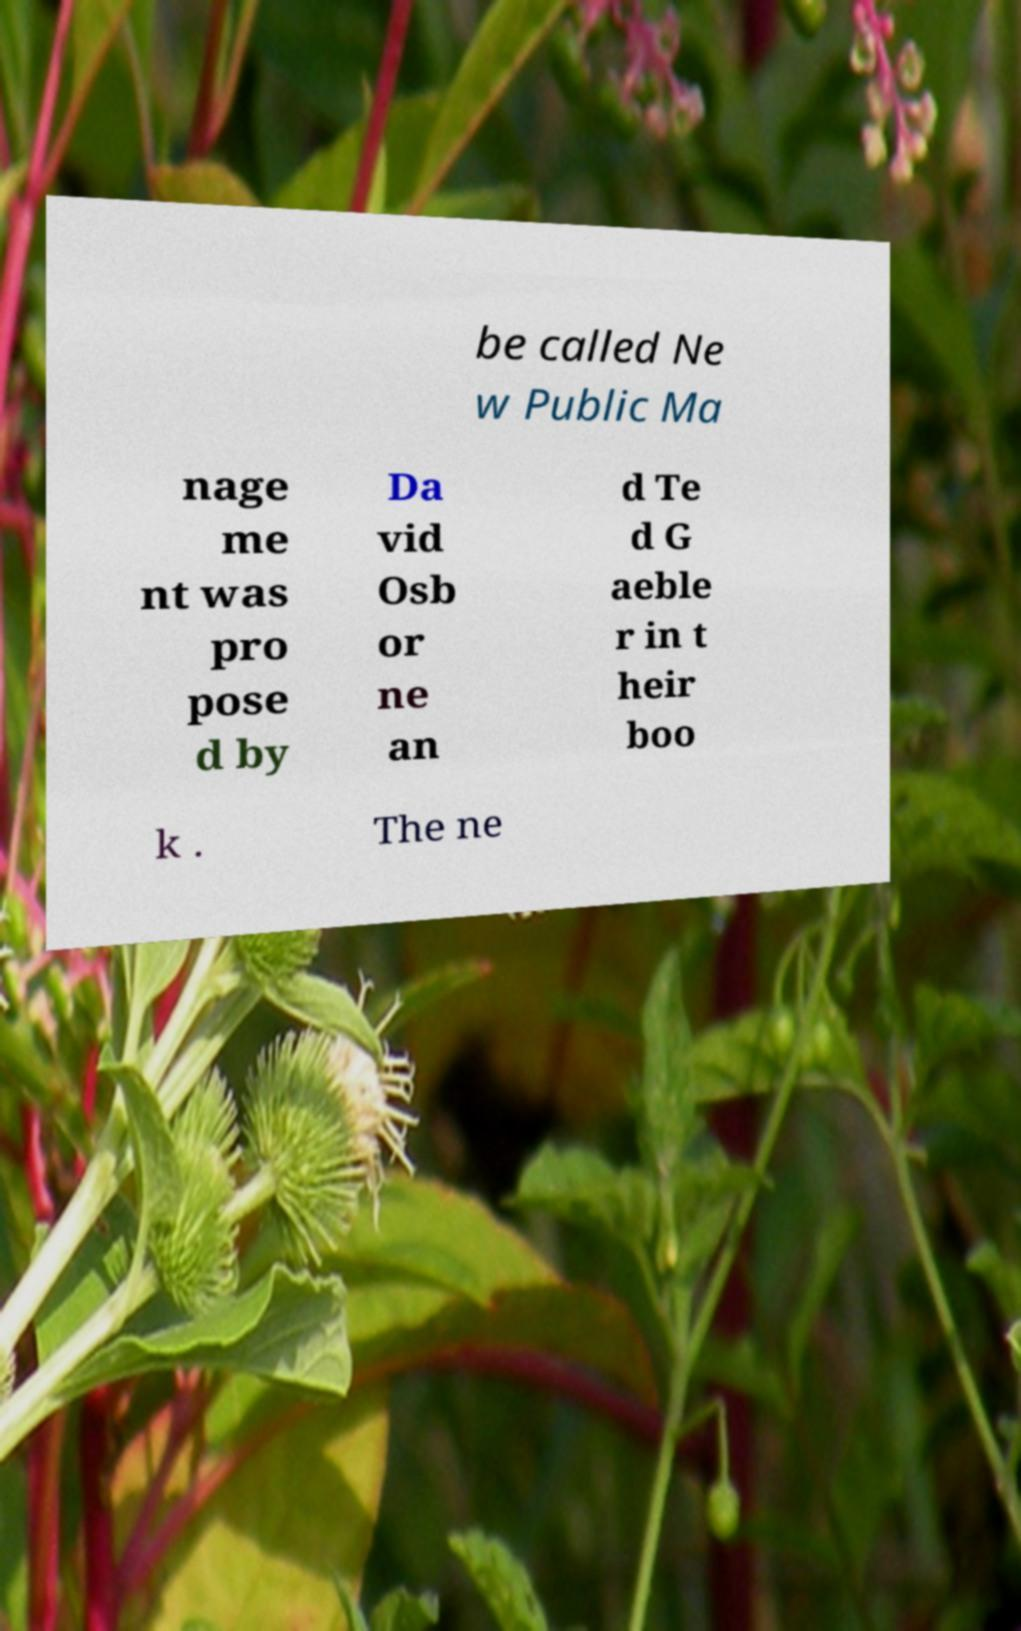Could you extract and type out the text from this image? be called Ne w Public Ma nage me nt was pro pose d by Da vid Osb or ne an d Te d G aeble r in t heir boo k . The ne 